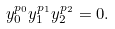Convert formula to latex. <formula><loc_0><loc_0><loc_500><loc_500>y _ { 0 } ^ { p _ { 0 } } y _ { 1 } ^ { p _ { 1 } } y _ { 2 } ^ { p _ { 2 } } = 0 .</formula> 